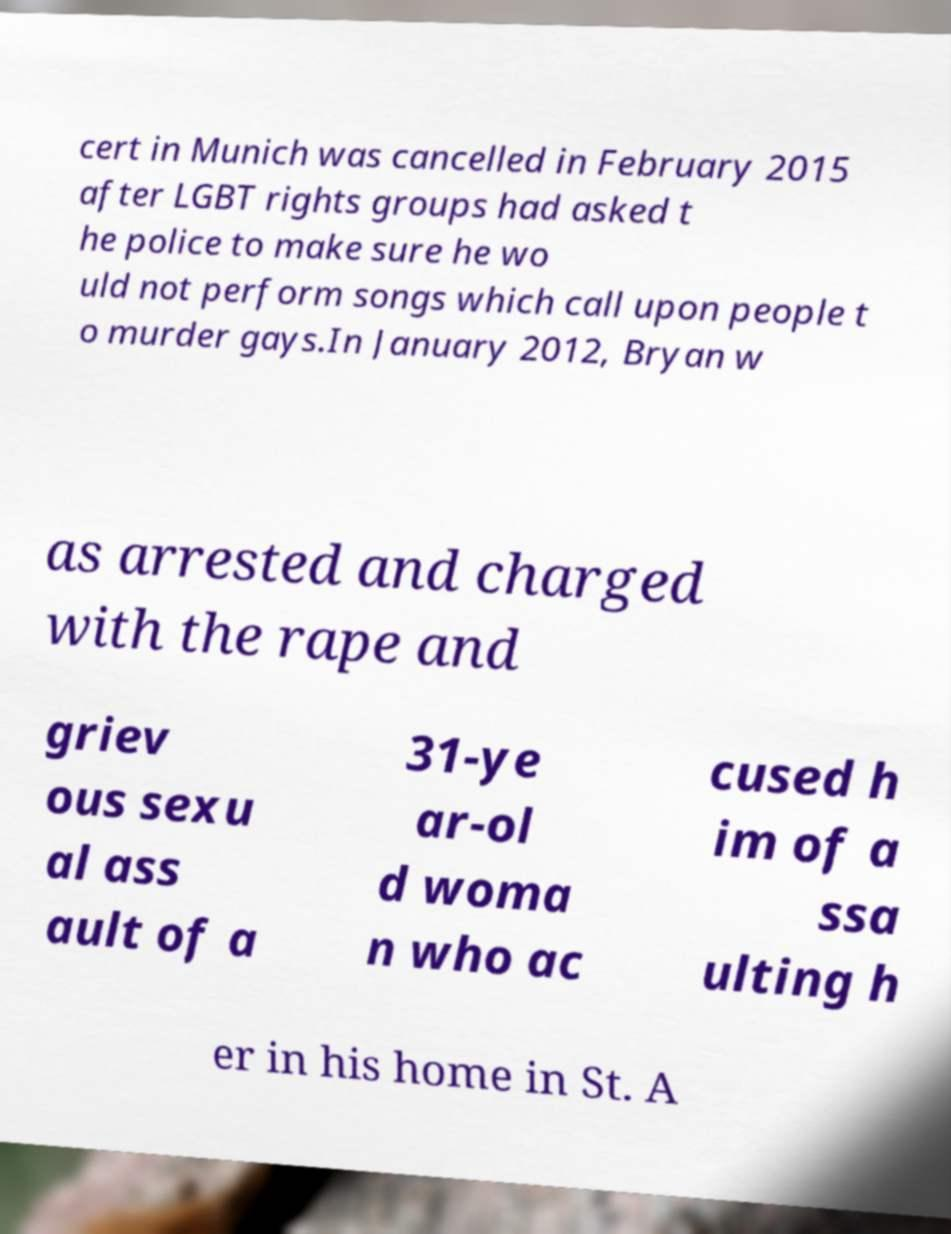Please read and relay the text visible in this image. What does it say? cert in Munich was cancelled in February 2015 after LGBT rights groups had asked t he police to make sure he wo uld not perform songs which call upon people t o murder gays.In January 2012, Bryan w as arrested and charged with the rape and griev ous sexu al ass ault of a 31-ye ar-ol d woma n who ac cused h im of a ssa ulting h er in his home in St. A 